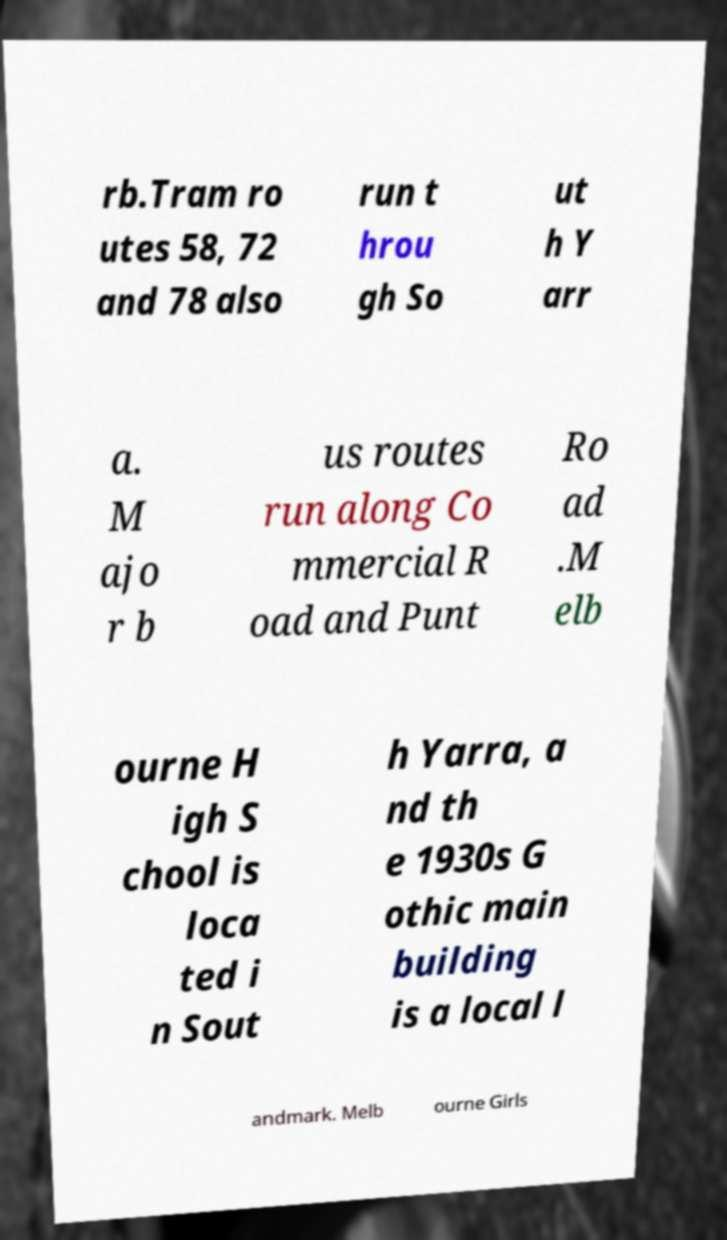Could you assist in decoding the text presented in this image and type it out clearly? rb.Tram ro utes 58, 72 and 78 also run t hrou gh So ut h Y arr a. M ajo r b us routes run along Co mmercial R oad and Punt Ro ad .M elb ourne H igh S chool is loca ted i n Sout h Yarra, a nd th e 1930s G othic main building is a local l andmark. Melb ourne Girls 